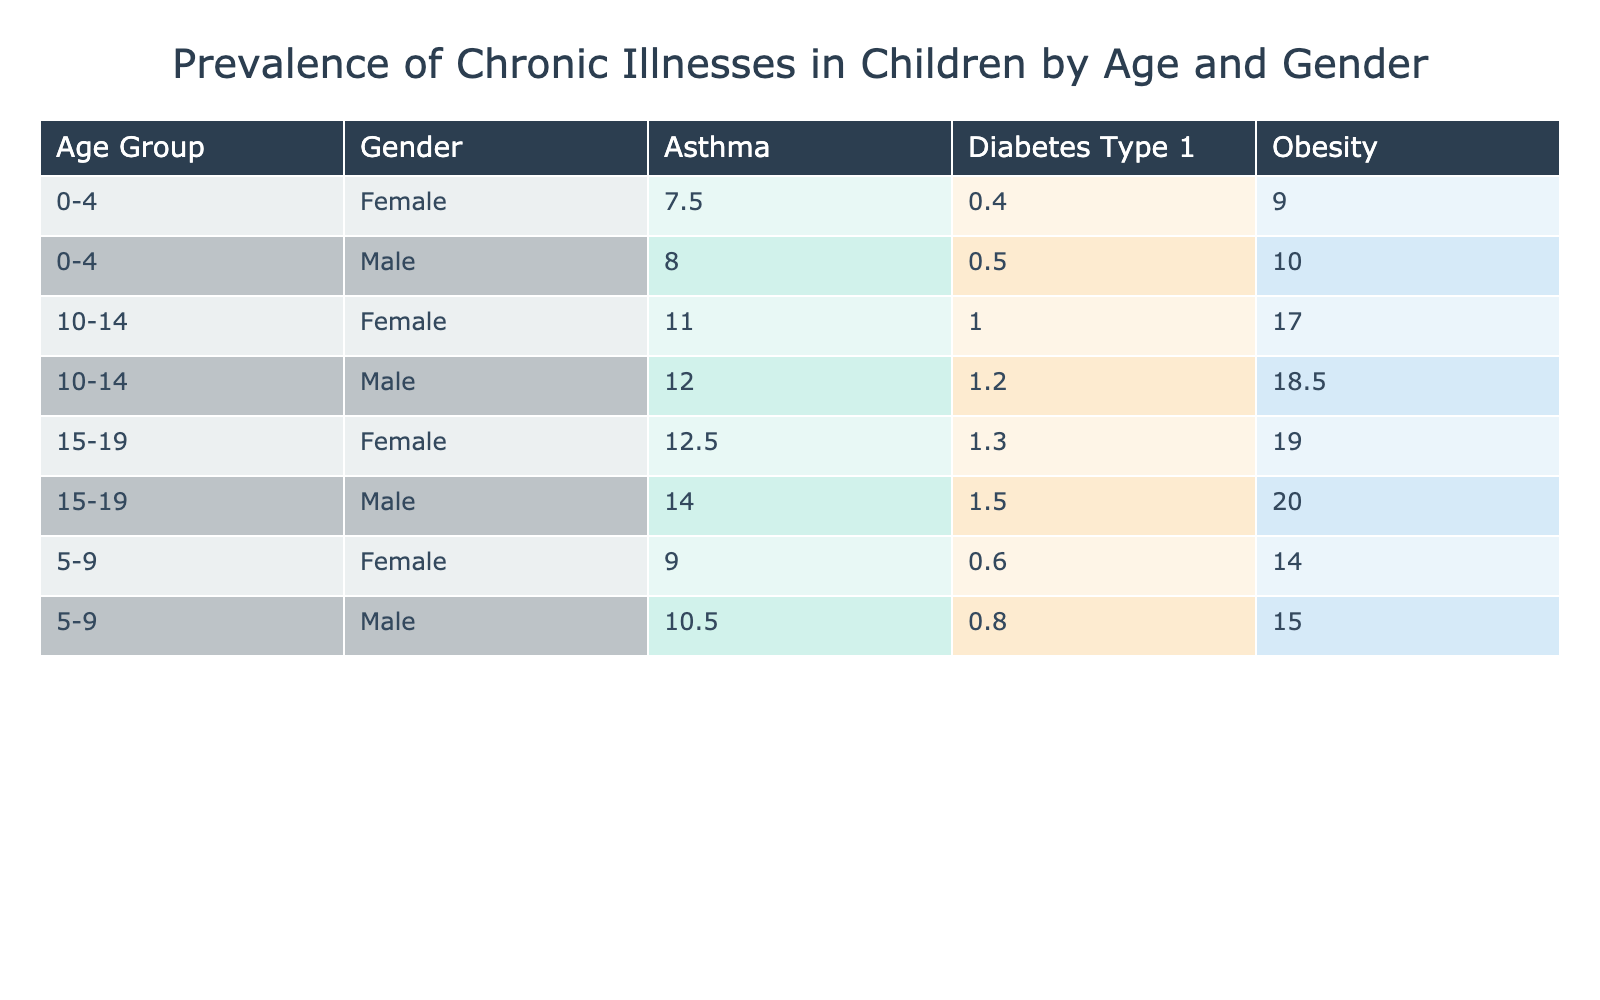What is the prevalence rate of asthma in males aged 0-4? According to the table, in the row for males in the age group 0-4, the prevalence rate for asthma is given as 8.0%.
Answer: 8.0% Which gender has a higher prevalence of obesity in the 5-9 age group? Looking at the age group 5-9, the prevalence rate for obesity in males is 15.0%, while for females it is 14.0%. Since 15.0% is greater than 14.0%, males have a higher prevalence.
Answer: Males What is the total prevalence rate of diabetes type 1 in females across all age groups? To find the total prevalence rate for females with diabetes type 1, I will sum the rates from all age groups: 0.4% (0-4) + 0.6% (5-9) + 1.0% (10-14) + 1.3% (15-19) = 3.3%.
Answer: 3.3% Is the prevalence of asthma higher in males or females in the 10-14 age group? In the 10-14 age group, males have a prevalence rate of 12.0% for asthma, while females have a prevalence rate of 11.0%. Since 12.0% is greater than 11.0%, the prevalence of asthma is higher in males.
Answer: Yes What is the average prevalence rate of obesity across all age groups for females? To find the average, we first sum the rates for obesity for females in each age group: 9.0% (0-4) + 14.0% (5-9) + 17.0% (10-14) + 19.0% (15-19) = 59.0%. We then divide this total by 4 (the number of age groups) to find the average: 59.0% / 4 = 14.75%.
Answer: 14.75% Does the prevalence of diabetes type 1 increase with age for males? Looking at the prevalence rates for males with diabetes type 1: 0.5% (0-4), 0.8% (5-9), 1.2% (10-14), and 1.5% (15-19), it indicates that as age increases, the prevalence rates also increase. Thus, the statement is true.
Answer: Yes 